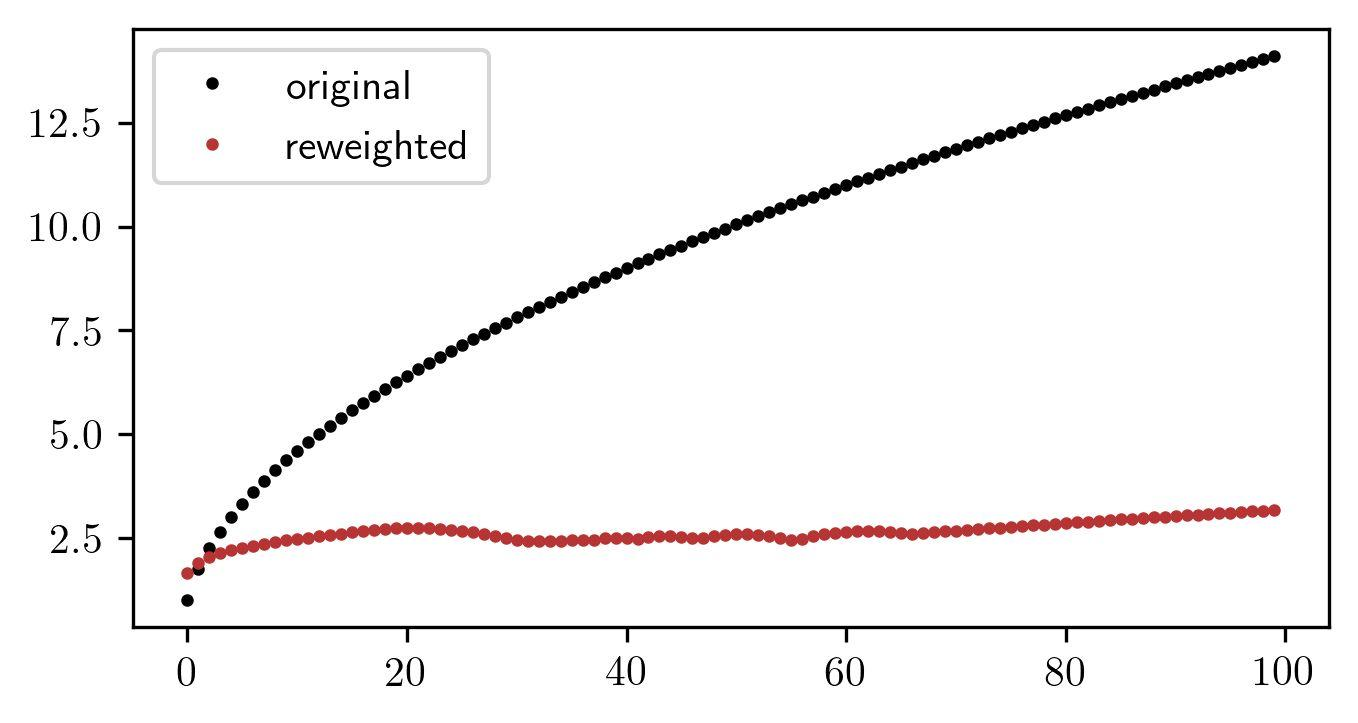Could the reweighted data points be clustered around a specific value for a particular reason? Yes, in statistical analysis, reweighted data points often converge around a specific value when they have been adjusted to minimize the impact of outliers or to reflect a re-balance based on a new methodology. In this graph, the clustering of the reweighted data around 2.5 might indicate that these data points have undergone a transformation or weighting process that causes them to represent a more standardized or normalized aspect of the measurement in question, effectively reducing variability and emphasizing a central trend or tendency in the data. 